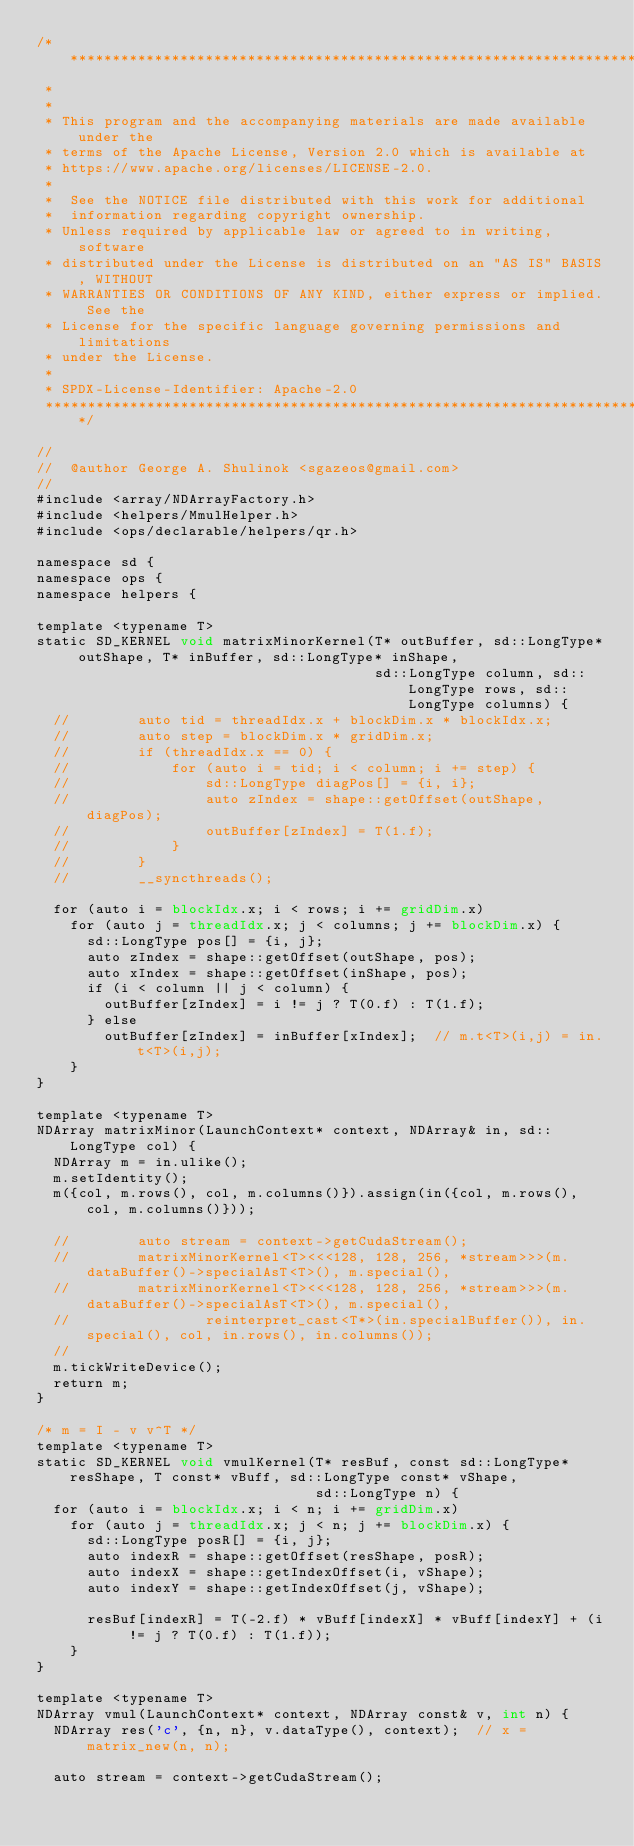Convert code to text. <code><loc_0><loc_0><loc_500><loc_500><_Cuda_>/* ******************************************************************************
 *
 *
 * This program and the accompanying materials are made available under the
 * terms of the Apache License, Version 2.0 which is available at
 * https://www.apache.org/licenses/LICENSE-2.0.
 *
 *  See the NOTICE file distributed with this work for additional
 *  information regarding copyright ownership.
 * Unless required by applicable law or agreed to in writing, software
 * distributed under the License is distributed on an "AS IS" BASIS, WITHOUT
 * WARRANTIES OR CONDITIONS OF ANY KIND, either express or implied. See the
 * License for the specific language governing permissions and limitations
 * under the License.
 *
 * SPDX-License-Identifier: Apache-2.0
 ******************************************************************************/

//
//  @author George A. Shulinok <sgazeos@gmail.com>
//
#include <array/NDArrayFactory.h>
#include <helpers/MmulHelper.h>
#include <ops/declarable/helpers/qr.h>

namespace sd {
namespace ops {
namespace helpers {

template <typename T>
static SD_KERNEL void matrixMinorKernel(T* outBuffer, sd::LongType* outShape, T* inBuffer, sd::LongType* inShape,
                                        sd::LongType column, sd::LongType rows, sd::LongType columns) {
  //        auto tid = threadIdx.x + blockDim.x * blockIdx.x;
  //        auto step = blockDim.x * gridDim.x;
  //        if (threadIdx.x == 0) {
  //            for (auto i = tid; i < column; i += step) {
  //                sd::LongType diagPos[] = {i, i};
  //                auto zIndex = shape::getOffset(outShape, diagPos);
  //                outBuffer[zIndex] = T(1.f);
  //            }
  //        }
  //        __syncthreads();

  for (auto i = blockIdx.x; i < rows; i += gridDim.x)
    for (auto j = threadIdx.x; j < columns; j += blockDim.x) {
      sd::LongType pos[] = {i, j};
      auto zIndex = shape::getOffset(outShape, pos);
      auto xIndex = shape::getOffset(inShape, pos);
      if (i < column || j < column) {
        outBuffer[zIndex] = i != j ? T(0.f) : T(1.f);
      } else
        outBuffer[zIndex] = inBuffer[xIndex];  // m.t<T>(i,j) = in.t<T>(i,j);
    }
}

template <typename T>
NDArray matrixMinor(LaunchContext* context, NDArray& in, sd::LongType col) {
  NDArray m = in.ulike();
  m.setIdentity();
  m({col, m.rows(), col, m.columns()}).assign(in({col, m.rows(), col, m.columns()}));

  //        auto stream = context->getCudaStream();
  //        matrixMinorKernel<T><<<128, 128, 256, *stream>>>(m.dataBuffer()->specialAsT<T>(), m.special(),
  //        matrixMinorKernel<T><<<128, 128, 256, *stream>>>(m.dataBuffer()->specialAsT<T>(), m.special(),
  //                reinterpret_cast<T*>(in.specialBuffer()), in.special(), col, in.rows(), in.columns());
  //
  m.tickWriteDevice();
  return m;
}

/* m = I - v v^T */
template <typename T>
static SD_KERNEL void vmulKernel(T* resBuf, const sd::LongType* resShape, T const* vBuff, sd::LongType const* vShape,
                                 sd::LongType n) {
  for (auto i = blockIdx.x; i < n; i += gridDim.x)
    for (auto j = threadIdx.x; j < n; j += blockDim.x) {
      sd::LongType posR[] = {i, j};
      auto indexR = shape::getOffset(resShape, posR);
      auto indexX = shape::getIndexOffset(i, vShape);
      auto indexY = shape::getIndexOffset(j, vShape);

      resBuf[indexR] = T(-2.f) * vBuff[indexX] * vBuff[indexY] + (i != j ? T(0.f) : T(1.f));
    }
}

template <typename T>
NDArray vmul(LaunchContext* context, NDArray const& v, int n) {
  NDArray res('c', {n, n}, v.dataType(), context);  // x = matrix_new(n, n);

  auto stream = context->getCudaStream();</code> 